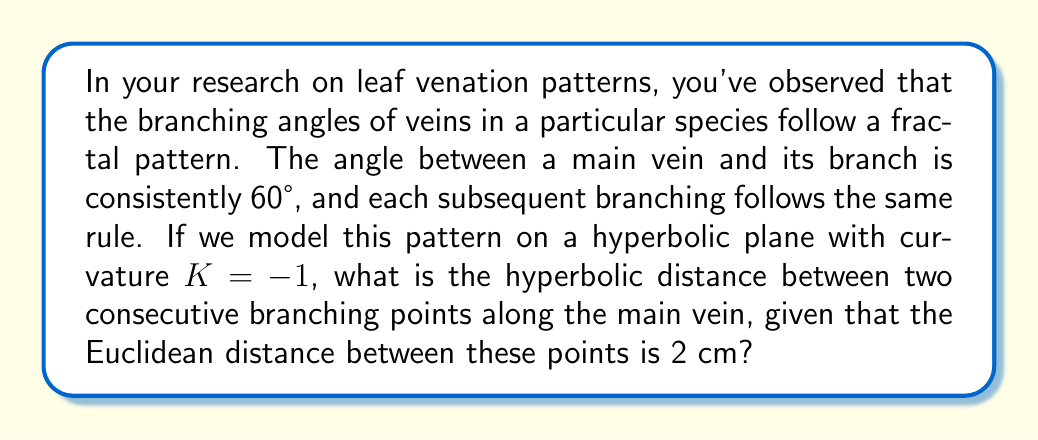Give your solution to this math problem. Let's approach this step-by-step:

1) In hyperbolic geometry, the relationship between Euclidean distance (d) and hyperbolic distance (s) on a plane with curvature K is given by:

   $$\sinh(\sqrt{-K}s) = \sqrt{-K}d$$

2) We're given that K = -1, so our equation simplifies to:

   $$\sinh(s) = d$$

3) We're also given that the Euclidean distance d = 2 cm. Substituting this:

   $$\sinh(s) = 2$$

4) To solve for s, we need to apply the inverse hyperbolic sine (arcsinh) to both sides:

   $$s = \arcsinh(2)$$

5) The arcsinh function can be expressed as:

   $$\arcsinh(x) = \ln(x + \sqrt{x^2 + 1})$$

6) Substituting x = 2:

   $$s = \ln(2 + \sqrt{2^2 + 1}) = \ln(2 + \sqrt{5})$$

7) This can be simplified to:

   $$s = \ln(2 + \sqrt{5}) \approx 1.7627$$

Thus, the hyperbolic distance between two consecutive branching points is approximately 1.7627 units in the hyperbolic plane.
Answer: $\ln(2 + \sqrt{5})$ hyperbolic units 